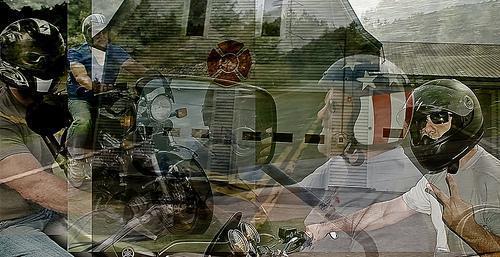How many people are in the picture?
Give a very brief answer. 4. 